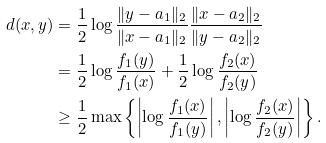<formula> <loc_0><loc_0><loc_500><loc_500>d ( x , y ) & = \frac { 1 } { 2 } \log \frac { \| y - a _ { 1 } \| _ { 2 } } { \| x - a _ { 1 } \| _ { 2 } } \frac { \| x - a _ { 2 } \| _ { 2 } } { \| y - a _ { 2 } \| _ { 2 } } \\ & = \frac { 1 } { 2 } \log \frac { f _ { 1 } ( y ) } { f _ { 1 } ( x ) } + \frac { 1 } { 2 } \log \frac { f _ { 2 } ( x ) } { f _ { 2 } ( y ) } \\ & \geq \frac { 1 } { 2 } \max \left \{ \left | \log \frac { f _ { 1 } ( x ) } { f _ { 1 } ( y ) } \right | , \left | \log \frac { f _ { 2 } ( x ) } { f _ { 2 } ( y ) } \right | \right \} .</formula> 